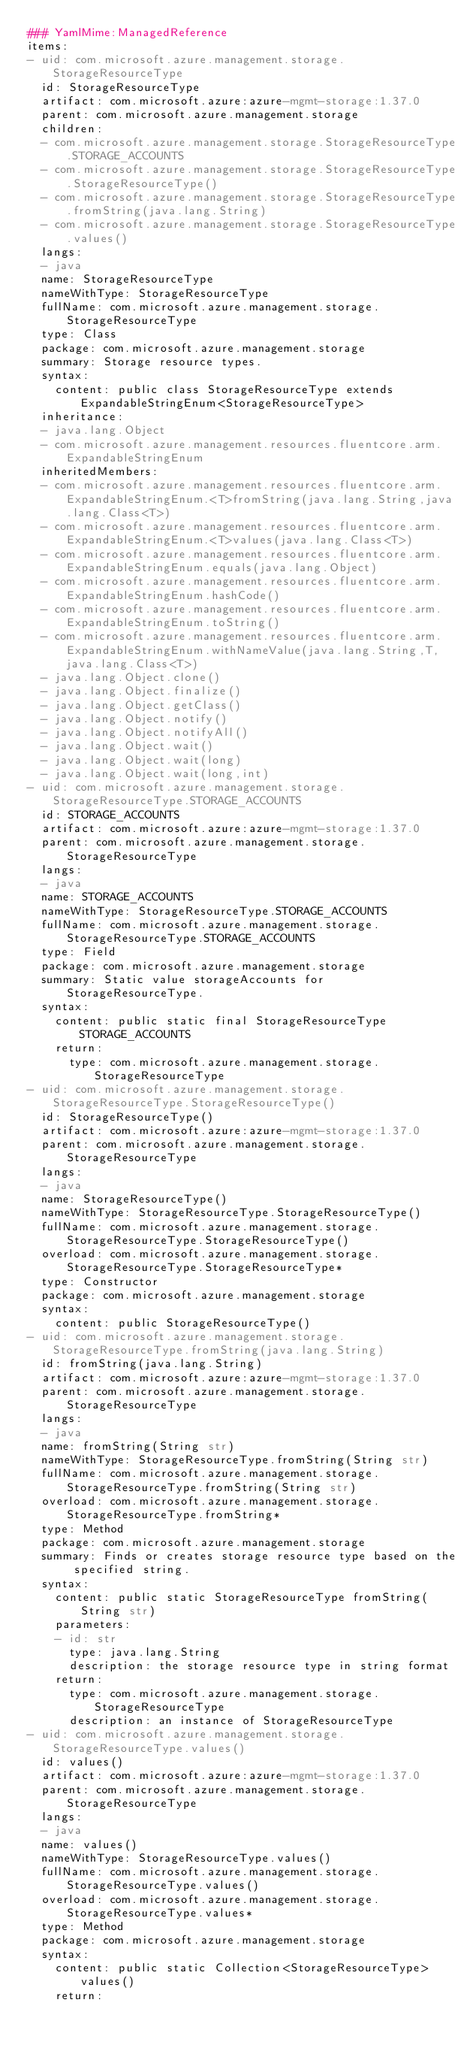Convert code to text. <code><loc_0><loc_0><loc_500><loc_500><_YAML_>### YamlMime:ManagedReference
items:
- uid: com.microsoft.azure.management.storage.StorageResourceType
  id: StorageResourceType
  artifact: com.microsoft.azure:azure-mgmt-storage:1.37.0
  parent: com.microsoft.azure.management.storage
  children:
  - com.microsoft.azure.management.storage.StorageResourceType.STORAGE_ACCOUNTS
  - com.microsoft.azure.management.storage.StorageResourceType.StorageResourceType()
  - com.microsoft.azure.management.storage.StorageResourceType.fromString(java.lang.String)
  - com.microsoft.azure.management.storage.StorageResourceType.values()
  langs:
  - java
  name: StorageResourceType
  nameWithType: StorageResourceType
  fullName: com.microsoft.azure.management.storage.StorageResourceType
  type: Class
  package: com.microsoft.azure.management.storage
  summary: Storage resource types.
  syntax:
    content: public class StorageResourceType extends ExpandableStringEnum<StorageResourceType>
  inheritance:
  - java.lang.Object
  - com.microsoft.azure.management.resources.fluentcore.arm.ExpandableStringEnum
  inheritedMembers:
  - com.microsoft.azure.management.resources.fluentcore.arm.ExpandableStringEnum.<T>fromString(java.lang.String,java.lang.Class<T>)
  - com.microsoft.azure.management.resources.fluentcore.arm.ExpandableStringEnum.<T>values(java.lang.Class<T>)
  - com.microsoft.azure.management.resources.fluentcore.arm.ExpandableStringEnum.equals(java.lang.Object)
  - com.microsoft.azure.management.resources.fluentcore.arm.ExpandableStringEnum.hashCode()
  - com.microsoft.azure.management.resources.fluentcore.arm.ExpandableStringEnum.toString()
  - com.microsoft.azure.management.resources.fluentcore.arm.ExpandableStringEnum.withNameValue(java.lang.String,T,java.lang.Class<T>)
  - java.lang.Object.clone()
  - java.lang.Object.finalize()
  - java.lang.Object.getClass()
  - java.lang.Object.notify()
  - java.lang.Object.notifyAll()
  - java.lang.Object.wait()
  - java.lang.Object.wait(long)
  - java.lang.Object.wait(long,int)
- uid: com.microsoft.azure.management.storage.StorageResourceType.STORAGE_ACCOUNTS
  id: STORAGE_ACCOUNTS
  artifact: com.microsoft.azure:azure-mgmt-storage:1.37.0
  parent: com.microsoft.azure.management.storage.StorageResourceType
  langs:
  - java
  name: STORAGE_ACCOUNTS
  nameWithType: StorageResourceType.STORAGE_ACCOUNTS
  fullName: com.microsoft.azure.management.storage.StorageResourceType.STORAGE_ACCOUNTS
  type: Field
  package: com.microsoft.azure.management.storage
  summary: Static value storageAccounts for StorageResourceType.
  syntax:
    content: public static final StorageResourceType STORAGE_ACCOUNTS
    return:
      type: com.microsoft.azure.management.storage.StorageResourceType
- uid: com.microsoft.azure.management.storage.StorageResourceType.StorageResourceType()
  id: StorageResourceType()
  artifact: com.microsoft.azure:azure-mgmt-storage:1.37.0
  parent: com.microsoft.azure.management.storage.StorageResourceType
  langs:
  - java
  name: StorageResourceType()
  nameWithType: StorageResourceType.StorageResourceType()
  fullName: com.microsoft.azure.management.storage.StorageResourceType.StorageResourceType()
  overload: com.microsoft.azure.management.storage.StorageResourceType.StorageResourceType*
  type: Constructor
  package: com.microsoft.azure.management.storage
  syntax:
    content: public StorageResourceType()
- uid: com.microsoft.azure.management.storage.StorageResourceType.fromString(java.lang.String)
  id: fromString(java.lang.String)
  artifact: com.microsoft.azure:azure-mgmt-storage:1.37.0
  parent: com.microsoft.azure.management.storage.StorageResourceType
  langs:
  - java
  name: fromString(String str)
  nameWithType: StorageResourceType.fromString(String str)
  fullName: com.microsoft.azure.management.storage.StorageResourceType.fromString(String str)
  overload: com.microsoft.azure.management.storage.StorageResourceType.fromString*
  type: Method
  package: com.microsoft.azure.management.storage
  summary: Finds or creates storage resource type based on the specified string.
  syntax:
    content: public static StorageResourceType fromString(String str)
    parameters:
    - id: str
      type: java.lang.String
      description: the storage resource type in string format
    return:
      type: com.microsoft.azure.management.storage.StorageResourceType
      description: an instance of StorageResourceType
- uid: com.microsoft.azure.management.storage.StorageResourceType.values()
  id: values()
  artifact: com.microsoft.azure:azure-mgmt-storage:1.37.0
  parent: com.microsoft.azure.management.storage.StorageResourceType
  langs:
  - java
  name: values()
  nameWithType: StorageResourceType.values()
  fullName: com.microsoft.azure.management.storage.StorageResourceType.values()
  overload: com.microsoft.azure.management.storage.StorageResourceType.values*
  type: Method
  package: com.microsoft.azure.management.storage
  syntax:
    content: public static Collection<StorageResourceType> values()
    return:</code> 